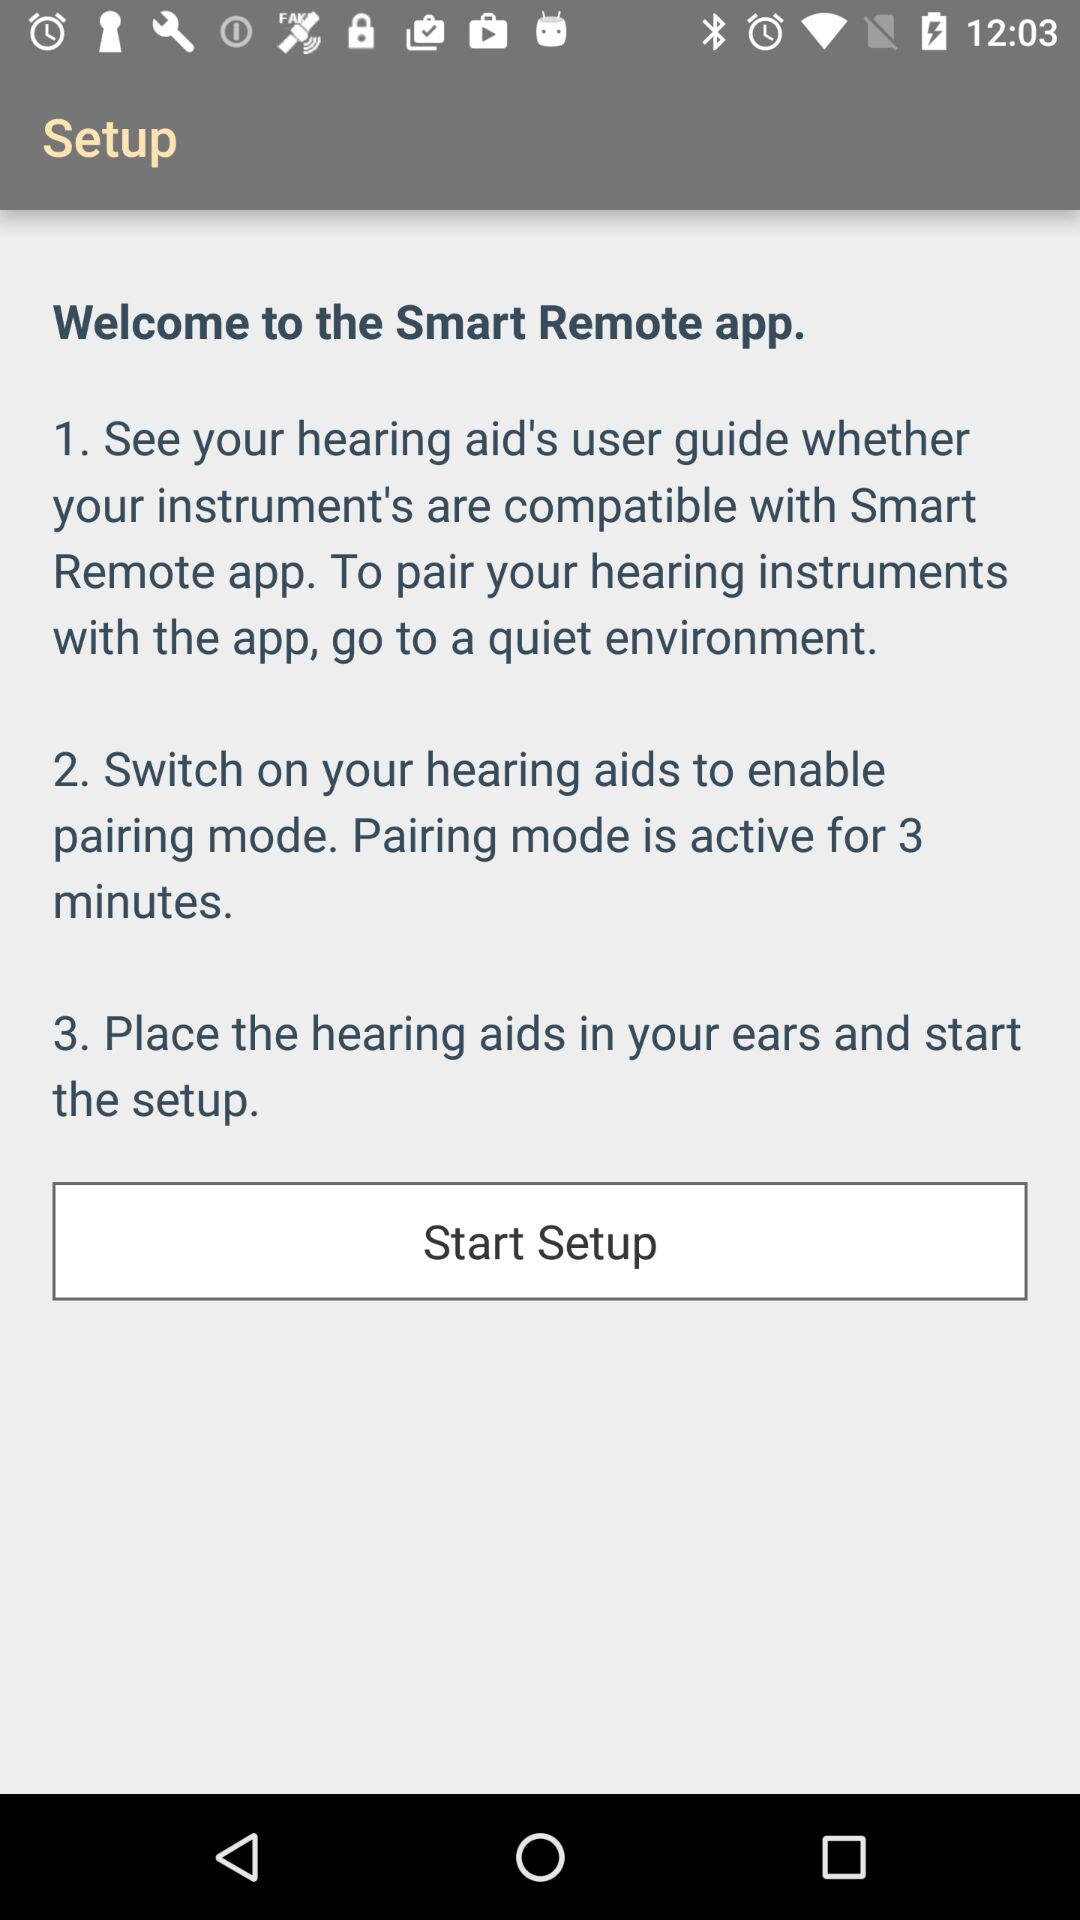How many steps are there to set up the hearing aids?
Answer the question using a single word or phrase. 3 